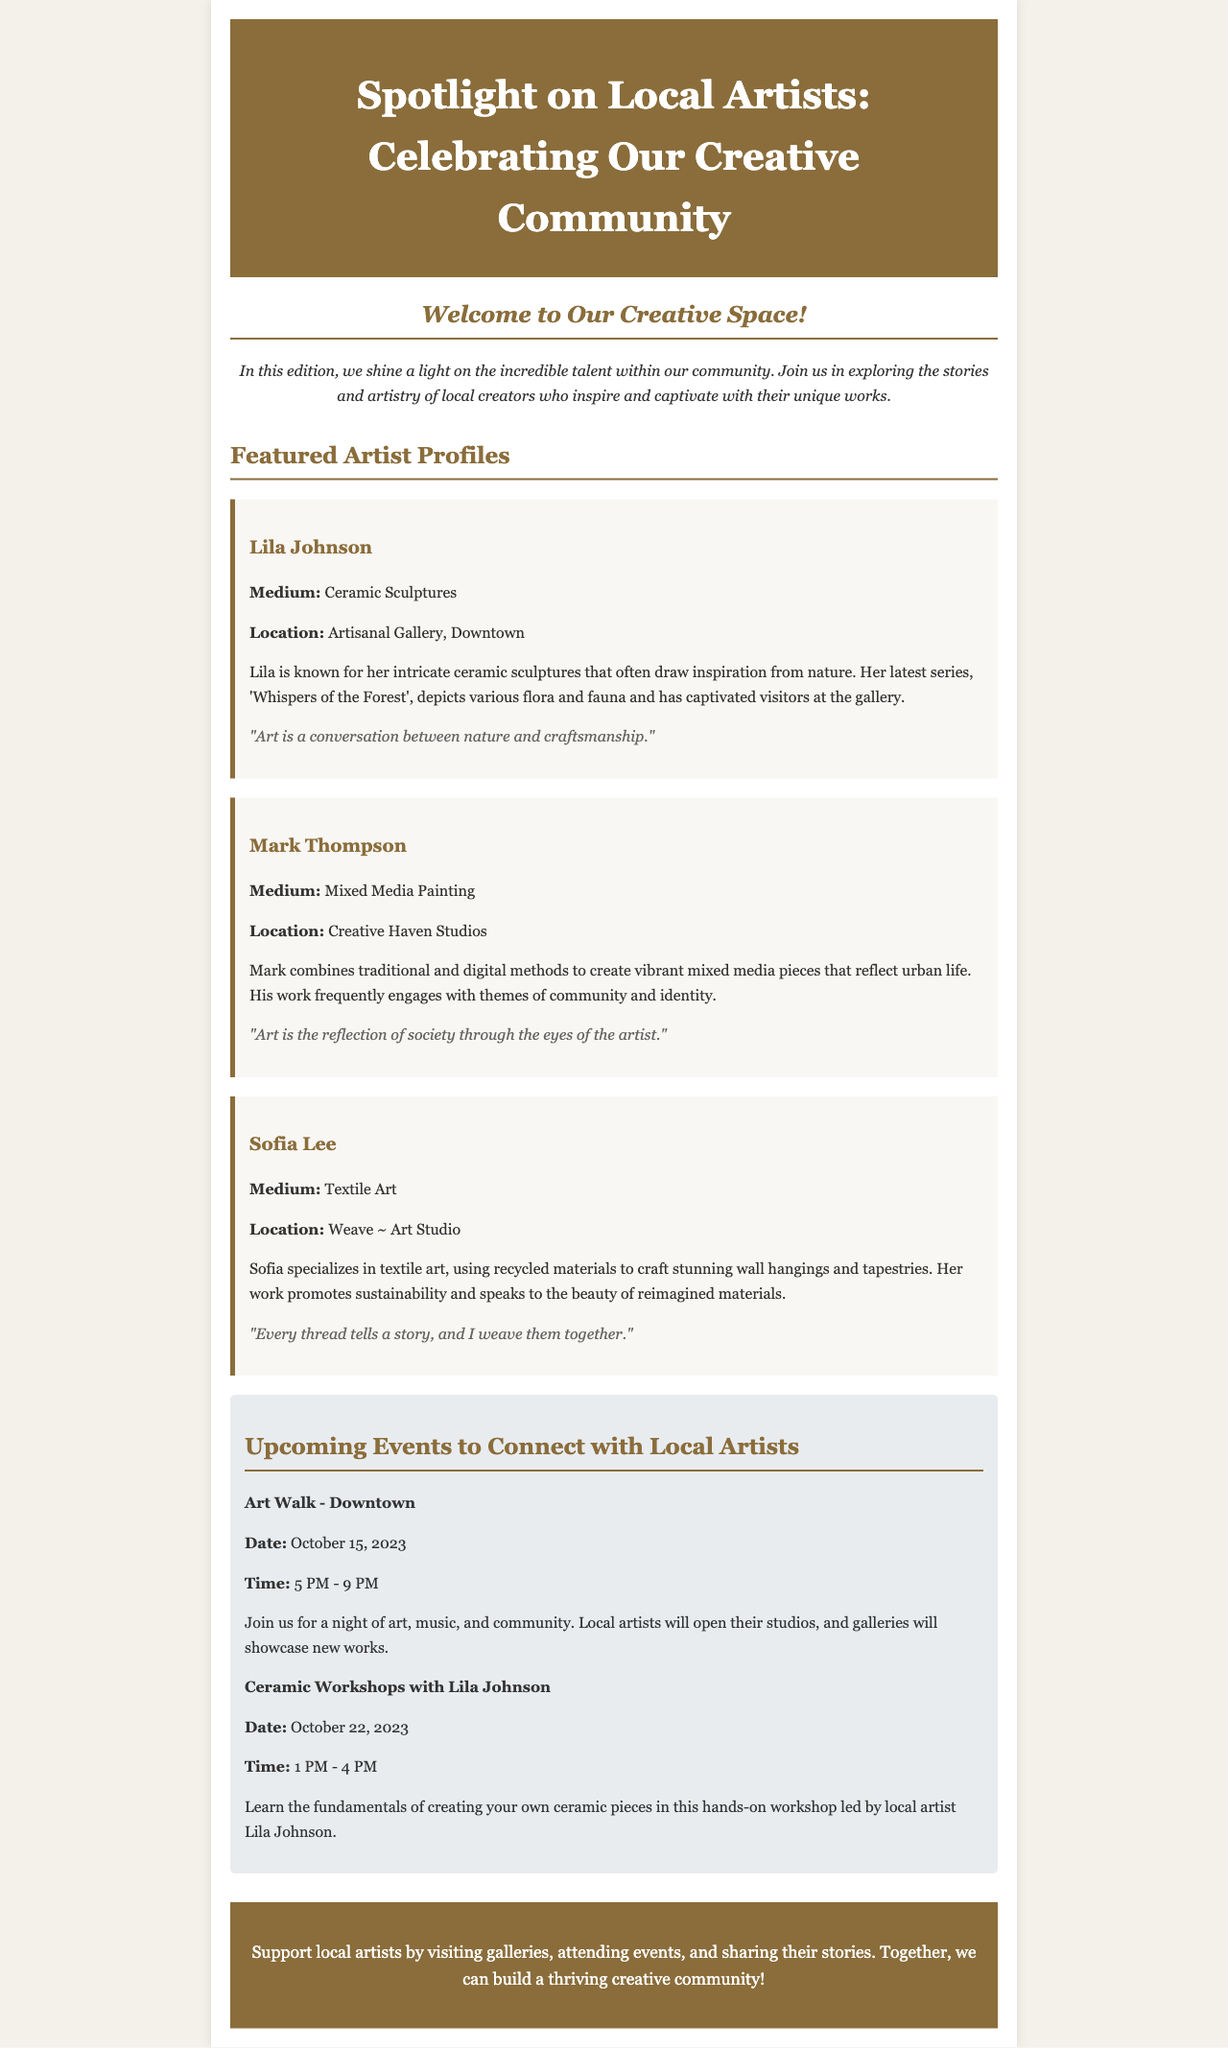What is the title of the newsletter? The title, prominently displayed at the top, is "Spotlight on Local Artists: Celebrating Our Creative Community."
Answer: Spotlight on Local Artists: Celebrating Our Creative Community Who is the featured artist specializing in ceramic sculptures? The document clearly states that Lila Johnson is the featured artist known for ceramic sculptures.
Answer: Lila Johnson What is the main theme of Lila Johnson's latest series? The document describes her series as depicting various flora and fauna, tying it to nature.
Answer: Whispers of the Forest When is the "Art Walk - Downtown" scheduled? The event is scheduled for a specific date mentioned as October 15, 2023.
Answer: October 15, 2023 What type of art does Sofia Lee create? The document specifies that Sofia Lee specializes in textile art, highlighting her use of recycled materials.
Answer: Textile Art What is the emphasis of Sofia Lee's work? The document notes that her work promotes sustainability and focuses on beauty, which is evident in her artistic approach.
Answer: Sustainability How many artists are featured in this edition? The document mentions three artists in the featured artist profiles section.
Answer: Three What is the date of the ceramic workshops with Lila Johnson? The date for the workshops is given precisely as October 22, 2023.
Answer: October 22, 2023 What will attendees do during the ceramic workshops? The document indicates that attendees will learn the fundamentals of creating their own ceramic pieces.
Answer: Create ceramic pieces 